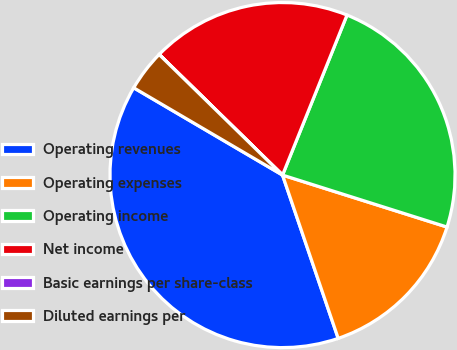Convert chart. <chart><loc_0><loc_0><loc_500><loc_500><pie_chart><fcel>Operating revenues<fcel>Operating expenses<fcel>Operating income<fcel>Net income<fcel>Basic earnings per share-class<fcel>Diluted earnings per<nl><fcel>38.67%<fcel>14.9%<fcel>23.77%<fcel>18.77%<fcel>0.01%<fcel>3.87%<nl></chart> 